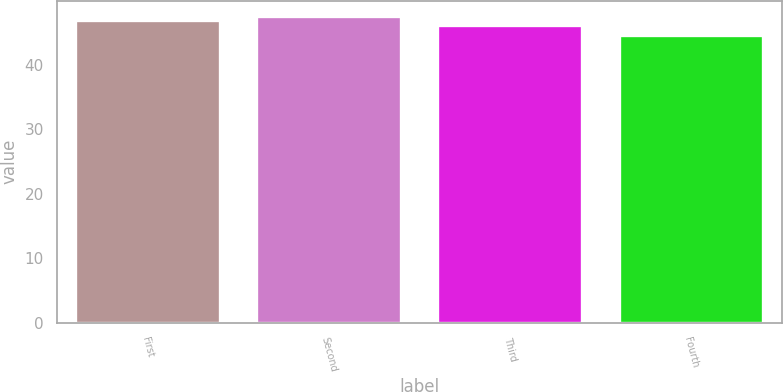Convert chart to OTSL. <chart><loc_0><loc_0><loc_500><loc_500><bar_chart><fcel>First<fcel>Second<fcel>Third<fcel>Fourth<nl><fcel>46.85<fcel>47.54<fcel>46.09<fcel>44.59<nl></chart> 